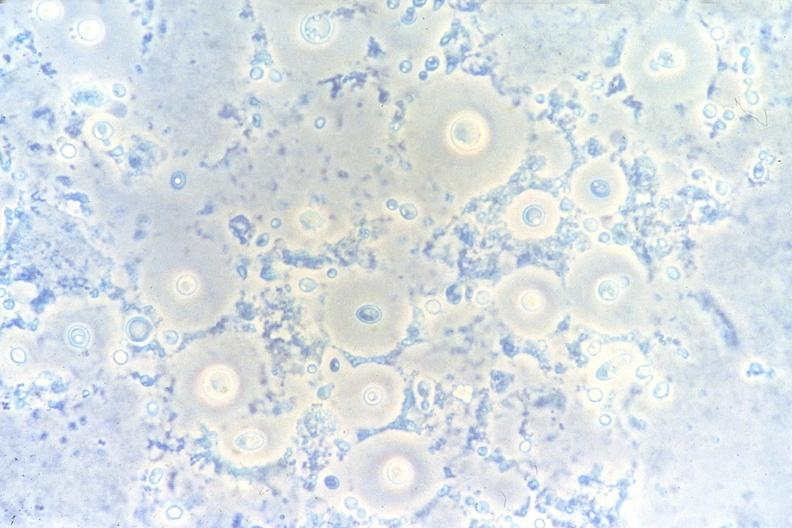where is this?
Answer the question using a single word or phrase. Lung 